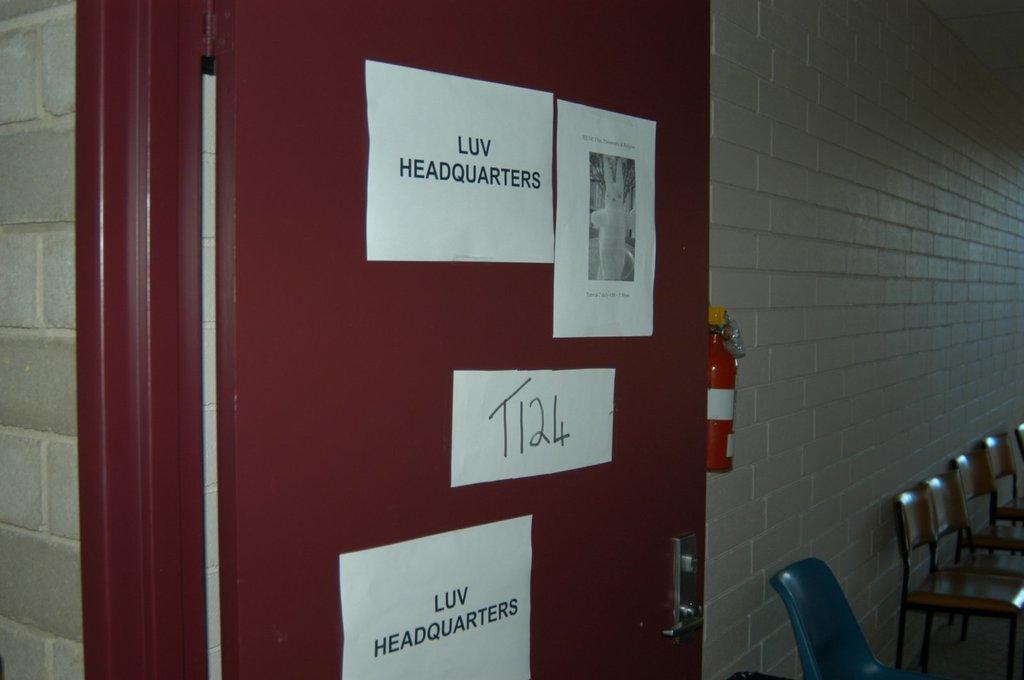Can you describe this image briefly? In this image I can see a maroon color door and few white color papers on it. I can see few chairs and emergency gas cylinder. The wall is in grey color. 